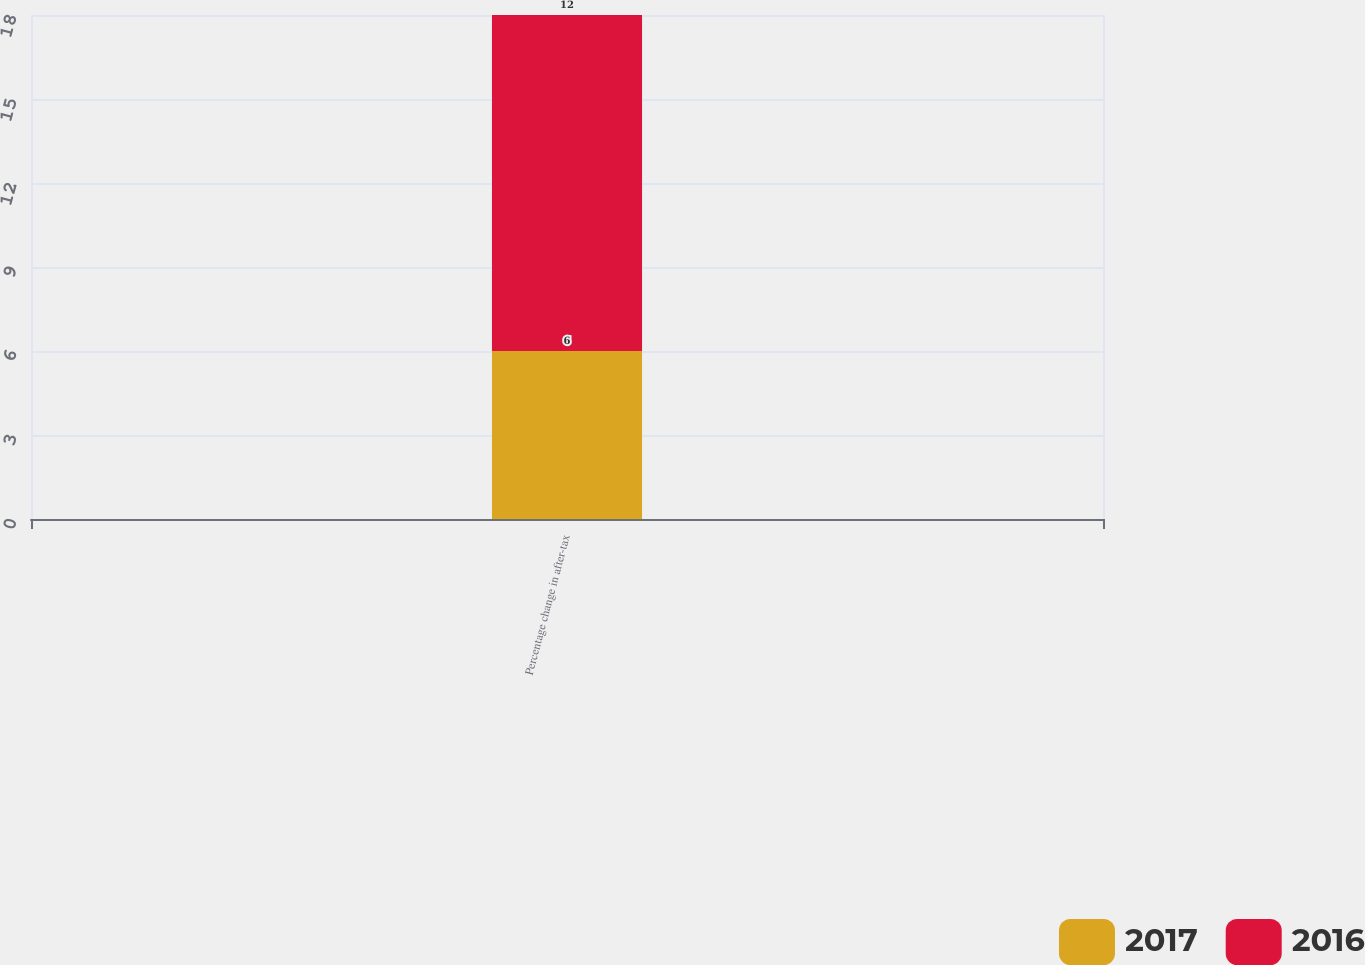Convert chart. <chart><loc_0><loc_0><loc_500><loc_500><stacked_bar_chart><ecel><fcel>Percentage change in after-tax<nl><fcel>2017<fcel>6<nl><fcel>2016<fcel>12<nl></chart> 